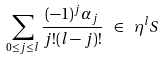Convert formula to latex. <formula><loc_0><loc_0><loc_500><loc_500>\sum _ { 0 \leq j \leq l } \frac { ( - 1 ) ^ { j } \alpha _ { j } } { j ! ( l - j ) ! } \ \in \ \eta ^ { l } S \,</formula> 